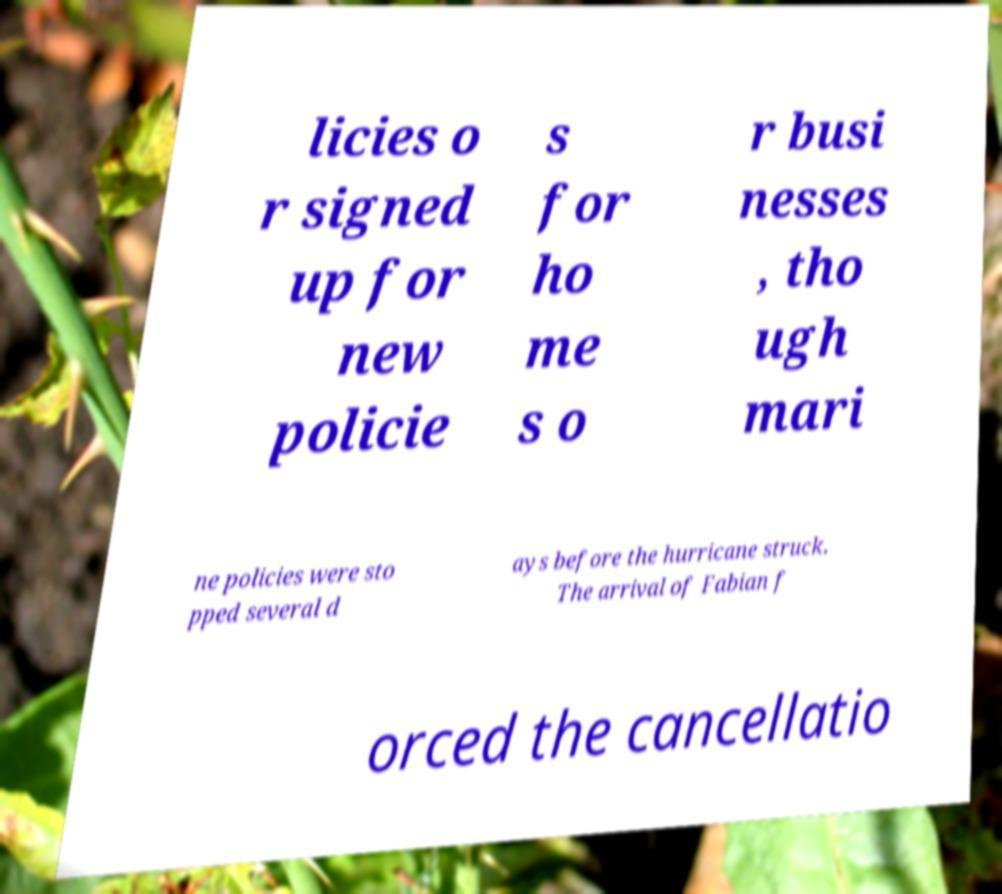Could you assist in decoding the text presented in this image and type it out clearly? licies o r signed up for new policie s for ho me s o r busi nesses , tho ugh mari ne policies were sto pped several d ays before the hurricane struck. The arrival of Fabian f orced the cancellatio 